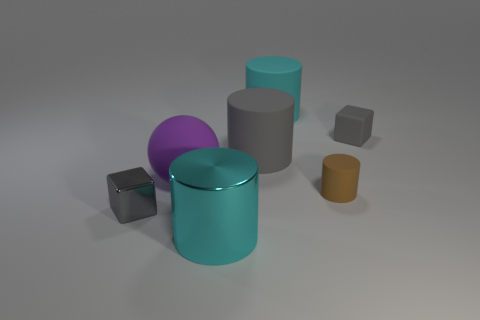Add 3 small cylinders. How many objects exist? 10 Subtract all blocks. How many objects are left? 5 Subtract 0 purple cubes. How many objects are left? 7 Subtract all large gray rubber cylinders. Subtract all small metallic objects. How many objects are left? 5 Add 2 purple balls. How many purple balls are left? 3 Add 6 big brown cylinders. How many big brown cylinders exist? 6 